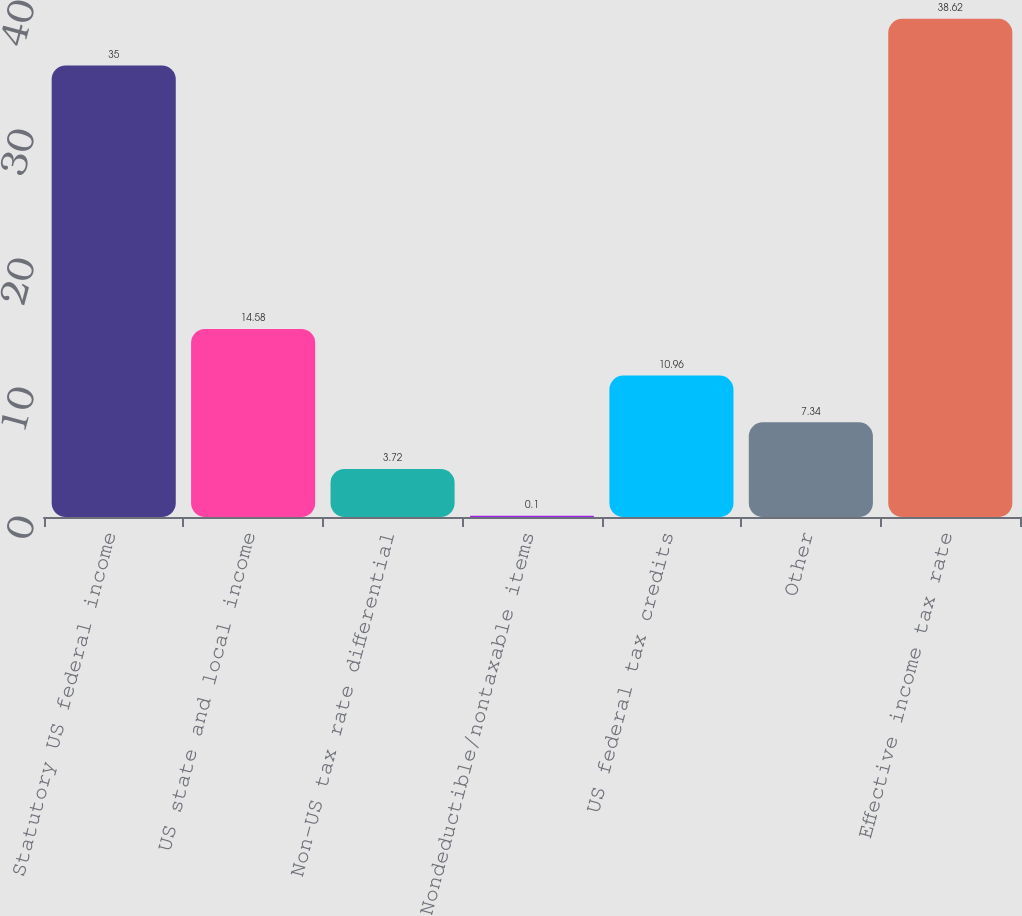<chart> <loc_0><loc_0><loc_500><loc_500><bar_chart><fcel>Statutory US federal income<fcel>US state and local income<fcel>Non-US tax rate differential<fcel>Nondeductible/nontaxable items<fcel>US federal tax credits<fcel>Other<fcel>Effective income tax rate<nl><fcel>35<fcel>14.58<fcel>3.72<fcel>0.1<fcel>10.96<fcel>7.34<fcel>38.62<nl></chart> 